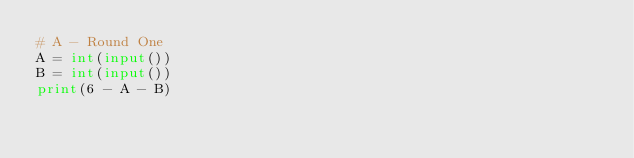<code> <loc_0><loc_0><loc_500><loc_500><_Python_># A - Round One
A = int(input())
B = int(input())
print(6 - A - B)</code> 